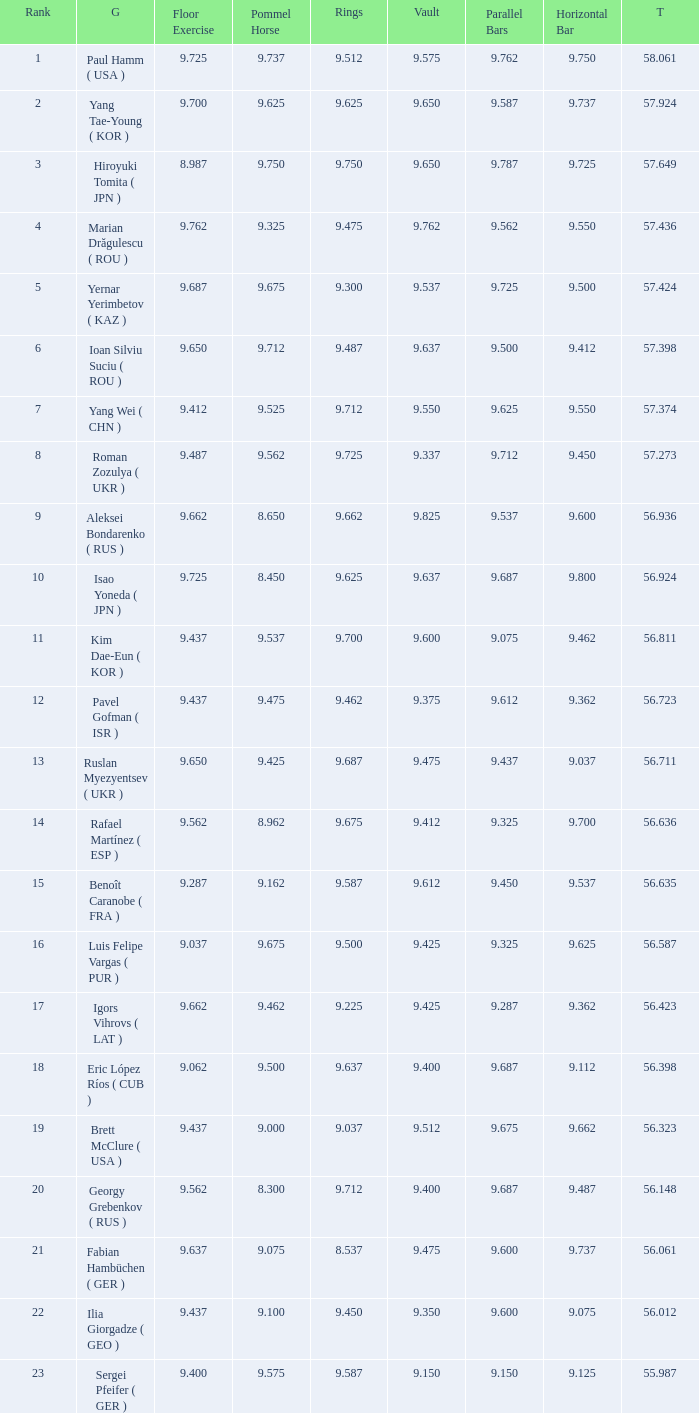What is the total score when the score for floor exercise was 9.287? 56.635. 